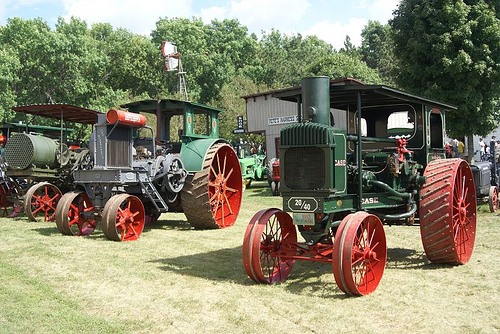<image>
Is the tractor in front of the tractor? No. The tractor is not in front of the tractor. The spatial positioning shows a different relationship between these objects. 